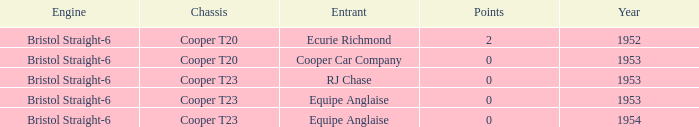Which entrant was present prior to 1953? Ecurie Richmond. Parse the full table. {'header': ['Engine', 'Chassis', 'Entrant', 'Points', 'Year'], 'rows': [['Bristol Straight-6', 'Cooper T20', 'Ecurie Richmond', '2', '1952'], ['Bristol Straight-6', 'Cooper T20', 'Cooper Car Company', '0', '1953'], ['Bristol Straight-6', 'Cooper T23', 'RJ Chase', '0', '1953'], ['Bristol Straight-6', 'Cooper T23', 'Equipe Anglaise', '0', '1953'], ['Bristol Straight-6', 'Cooper T23', 'Equipe Anglaise', '0', '1954']]} 